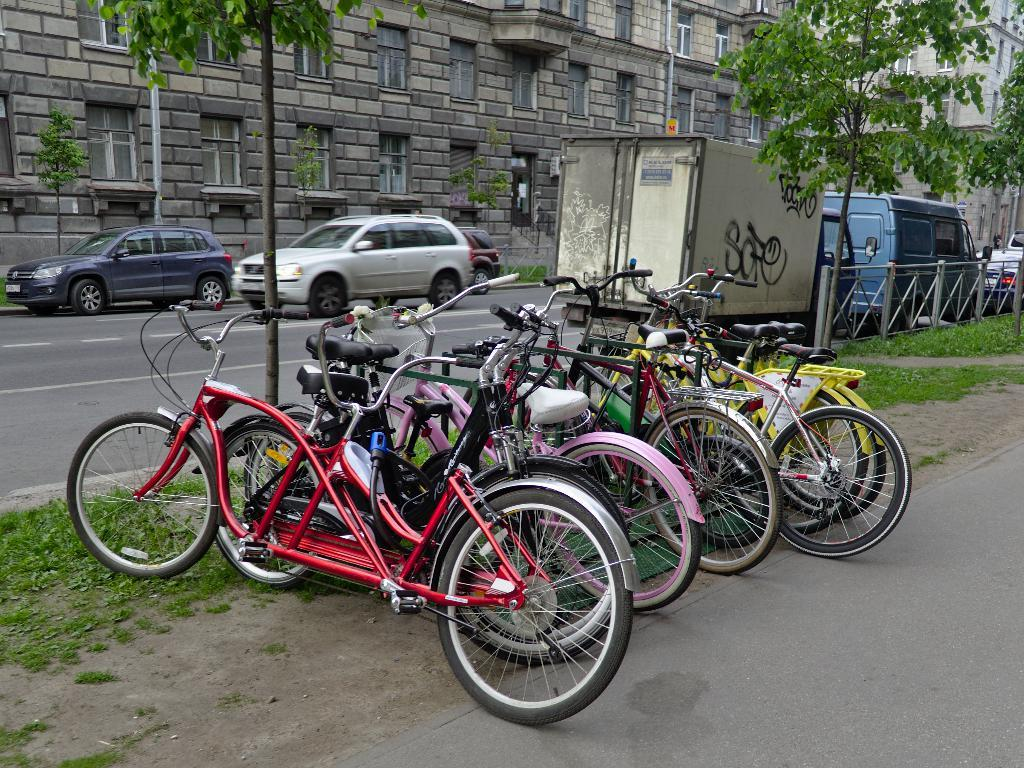What type of transportation can be seen in the image? There are bicycles in the image. What natural elements are present in the image? There are trees and grass in the image. What man-made structure can be seen in the image? There is a fence in the image. What else is visible on the ground in the image? There are vehicles on the road in the image. What can be seen in the distance in the image? There are buildings in the background of the image. What is the name of the yak in the image? There is no yak present in the image. Can you tell me what your mom is doing in the image? The image does not depict any person, let alone a mom, so it is not possible to answer that question. 